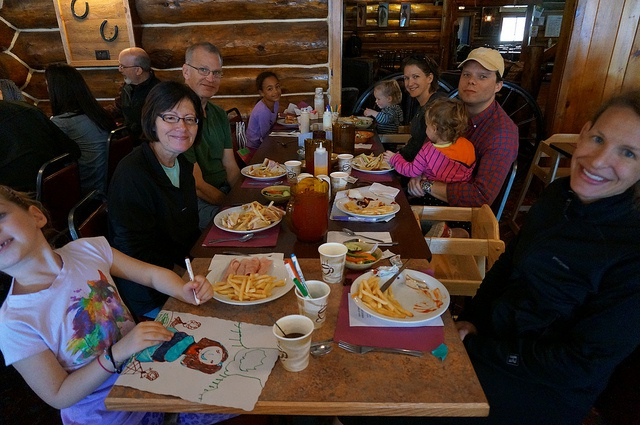Describe the objects in this image and their specific colors. I can see dining table in gray and maroon tones, people in gray, black, and maroon tones, people in gray and darkgray tones, people in gray, black, and maroon tones, and people in gray, maroon, black, brown, and tan tones in this image. 